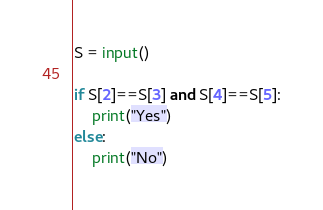Convert code to text. <code><loc_0><loc_0><loc_500><loc_500><_Python_>S = input()
 
if S[2]==S[3] and S[4]==S[5]:
    print("Yes")
else:
    print("No")</code> 